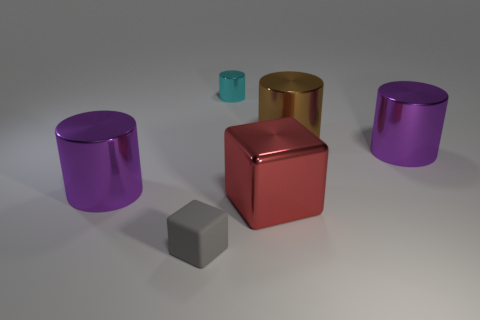Are the gray thing and the brown cylinder made of the same material?
Keep it short and to the point. No. How many things are red cubes or large blue metallic balls?
Make the answer very short. 1. How many large red cubes are the same material as the big brown object?
Provide a short and direct response. 1. There is another object that is the same shape as the gray object; what size is it?
Make the answer very short. Large. Are there any purple cylinders to the right of the small gray cube?
Offer a very short reply. Yes. What material is the tiny gray cube?
Provide a succinct answer. Rubber. There is a object that is behind the large brown cylinder; is it the same color as the tiny cube?
Make the answer very short. No. Is there any other thing that has the same shape as the small gray matte thing?
Provide a short and direct response. Yes. The tiny shiny object that is the same shape as the big brown metallic object is what color?
Provide a short and direct response. Cyan. There is a small object that is behind the large red metal object; what is it made of?
Your answer should be very brief. Metal. 